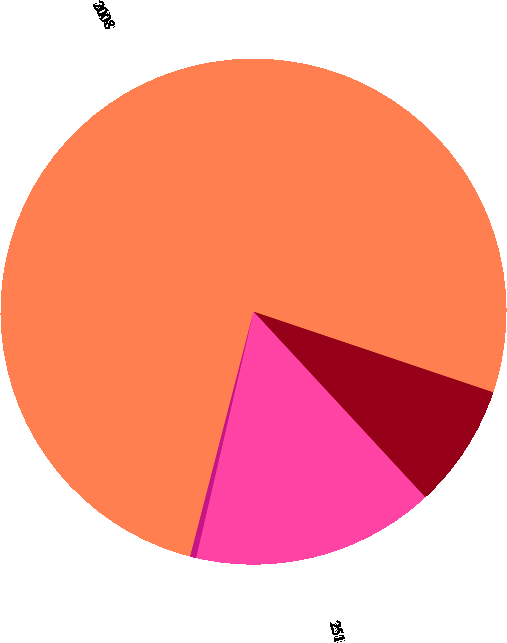<chart> <loc_0><loc_0><loc_500><loc_500><pie_chart><fcel>2008<fcel>253<fcel>251<fcel>111<nl><fcel>76.14%<fcel>7.95%<fcel>15.53%<fcel>0.38%<nl></chart> 